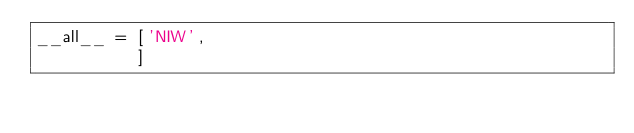<code> <loc_0><loc_0><loc_500><loc_500><_Python_>__all__ = ['NIW',
          ]</code> 